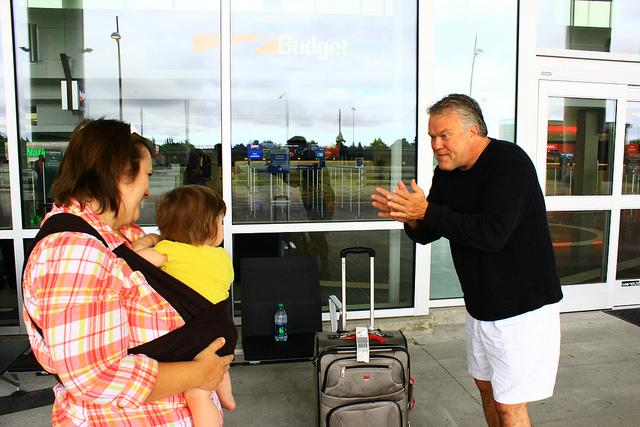What is the woman carrying? baby 